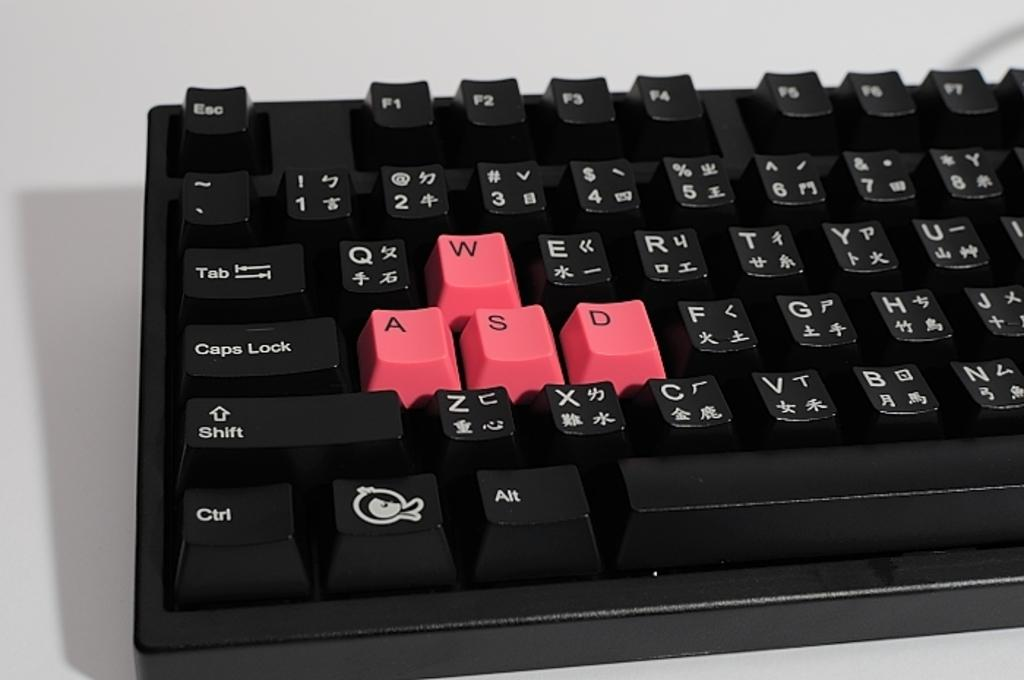<image>
Offer a succinct explanation of the picture presented. Black keyboard with the pink keys for W,A,S, and D. 